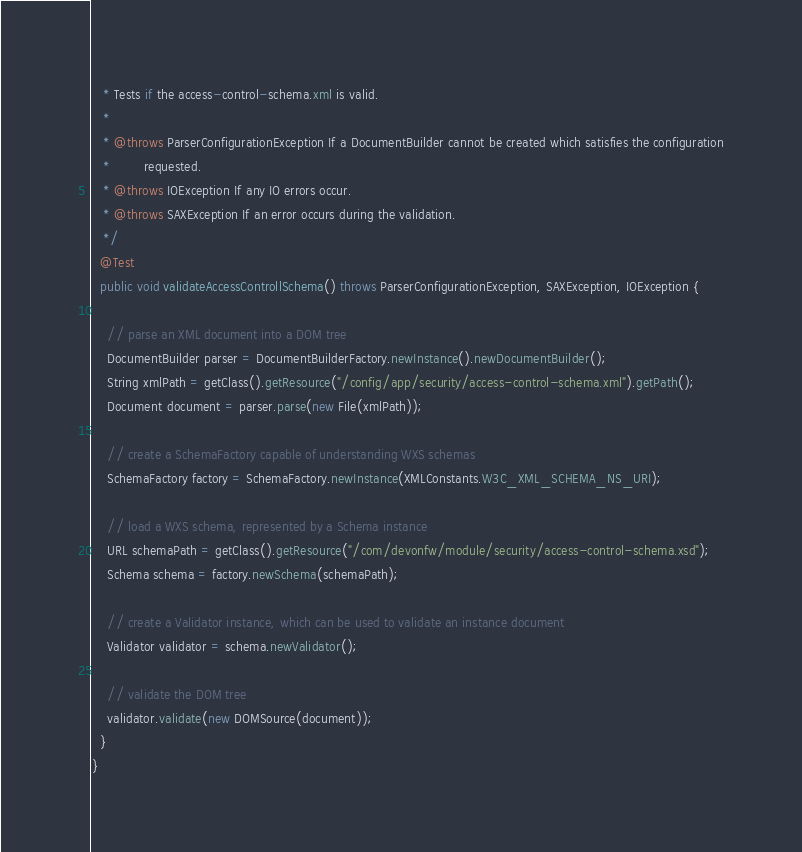Convert code to text. <code><loc_0><loc_0><loc_500><loc_500><_Java_>   * Tests if the access-control-schema.xml is valid.
   *
   * @throws ParserConfigurationException If a DocumentBuilder cannot be created which satisfies the configuration
   *         requested.
   * @throws IOException If any IO errors occur.
   * @throws SAXException If an error occurs during the validation.
   */
  @Test
  public void validateAccessControllSchema() throws ParserConfigurationException, SAXException, IOException {

    // parse an XML document into a DOM tree
    DocumentBuilder parser = DocumentBuilderFactory.newInstance().newDocumentBuilder();
    String xmlPath = getClass().getResource("/config/app/security/access-control-schema.xml").getPath();
    Document document = parser.parse(new File(xmlPath));

    // create a SchemaFactory capable of understanding WXS schemas
    SchemaFactory factory = SchemaFactory.newInstance(XMLConstants.W3C_XML_SCHEMA_NS_URI);

    // load a WXS schema, represented by a Schema instance
    URL schemaPath = getClass().getResource("/com/devonfw/module/security/access-control-schema.xsd");
    Schema schema = factory.newSchema(schemaPath);

    // create a Validator instance, which can be used to validate an instance document
    Validator validator = schema.newValidator();

    // validate the DOM tree
    validator.validate(new DOMSource(document));
  }
}
</code> 